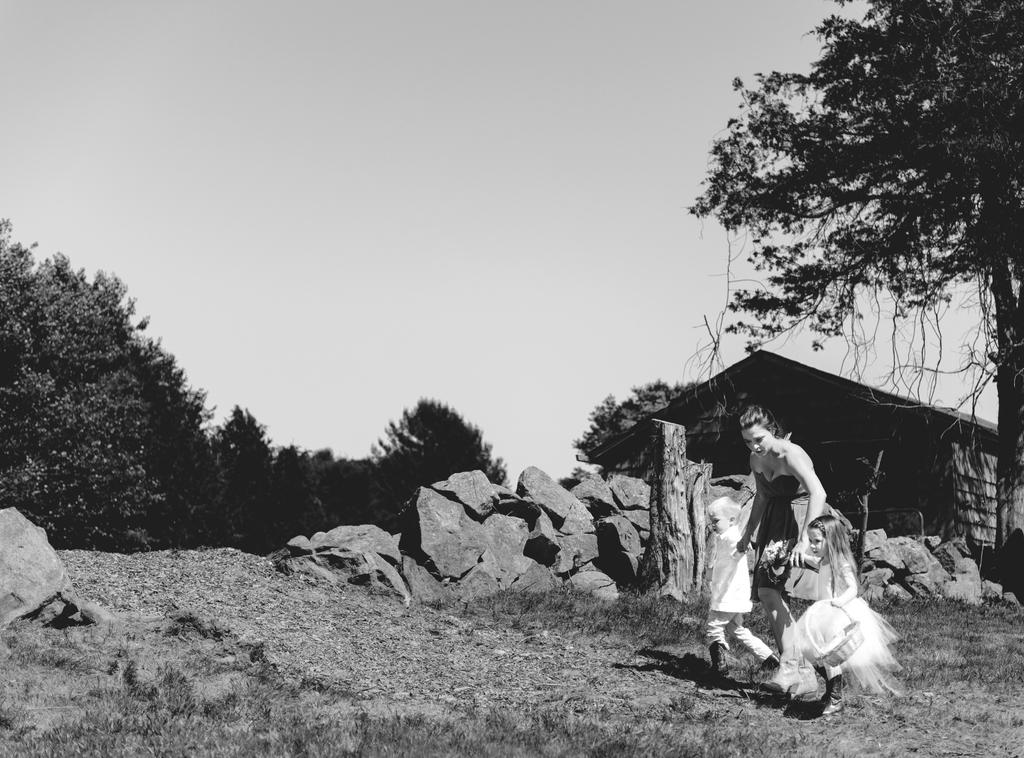What is the color scheme of the image? The image is black and white. What are the people in the image doing? There are 3 people walking on the grass in the image. In which direction are the people walking? The people are walking towards the left. What other natural elements can be seen in the image? There are rocks, trees, and grass in the image. What type of structure is present in the image? There is a house in the image. What type of bells can be heard ringing in the image? There are no bells present in the image, and therefore no sound can be heard. What kind of toys are the people playing with in the image? There are no toys visible in the image; the people are simply walking on the grass. 